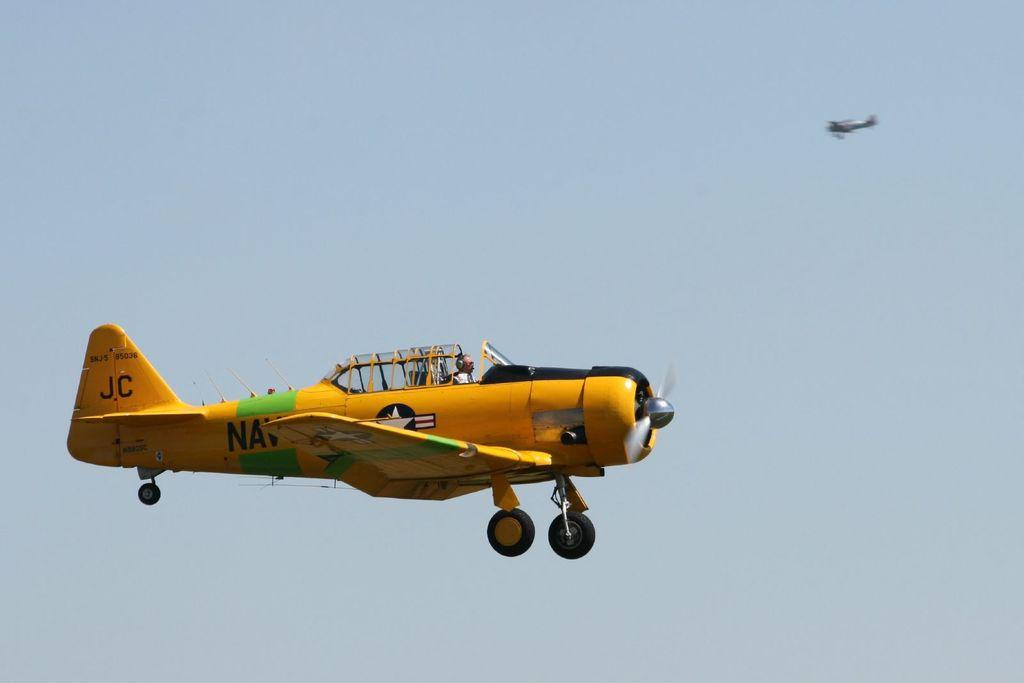<image>
Render a clear and concise summary of the photo. the initials JC on the back of a plane 